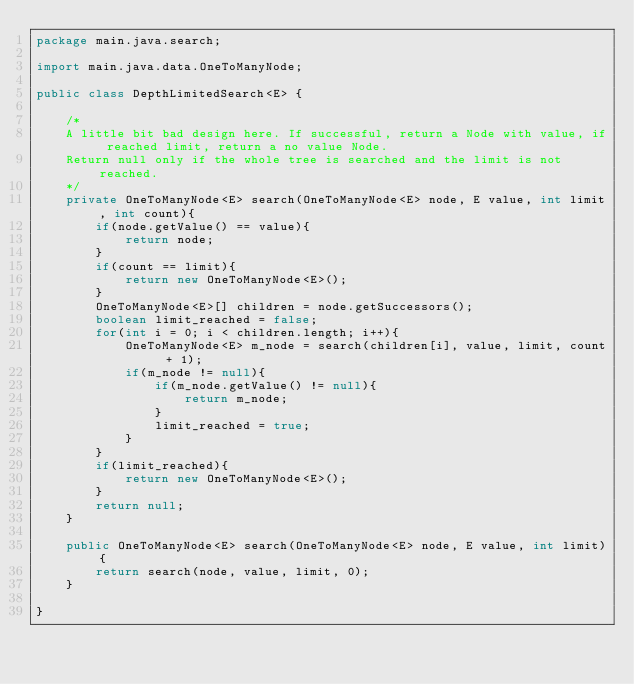Convert code to text. <code><loc_0><loc_0><loc_500><loc_500><_Java_>package main.java.search;

import main.java.data.OneToManyNode;

public class DepthLimitedSearch<E> {

    /*
    A little bit bad design here. If successful, return a Node with value, if reached limit, return a no value Node.
    Return null only if the whole tree is searched and the limit is not reached.
    */
    private OneToManyNode<E> search(OneToManyNode<E> node, E value, int limit, int count){
        if(node.getValue() == value){
            return node;
        }
        if(count == limit){
            return new OneToManyNode<E>();
        }
        OneToManyNode<E>[] children = node.getSuccessors();
        boolean limit_reached = false;
        for(int i = 0; i < children.length; i++){
            OneToManyNode<E> m_node = search(children[i], value, limit, count + 1);
            if(m_node != null){
                if(m_node.getValue() != null){
                    return m_node;
                }
                limit_reached = true;
            }
        }
        if(limit_reached){
            return new OneToManyNode<E>();
        }
        return null;
    }

    public OneToManyNode<E> search(OneToManyNode<E> node, E value, int limit){
        return search(node, value, limit, 0);
    }

}
</code> 